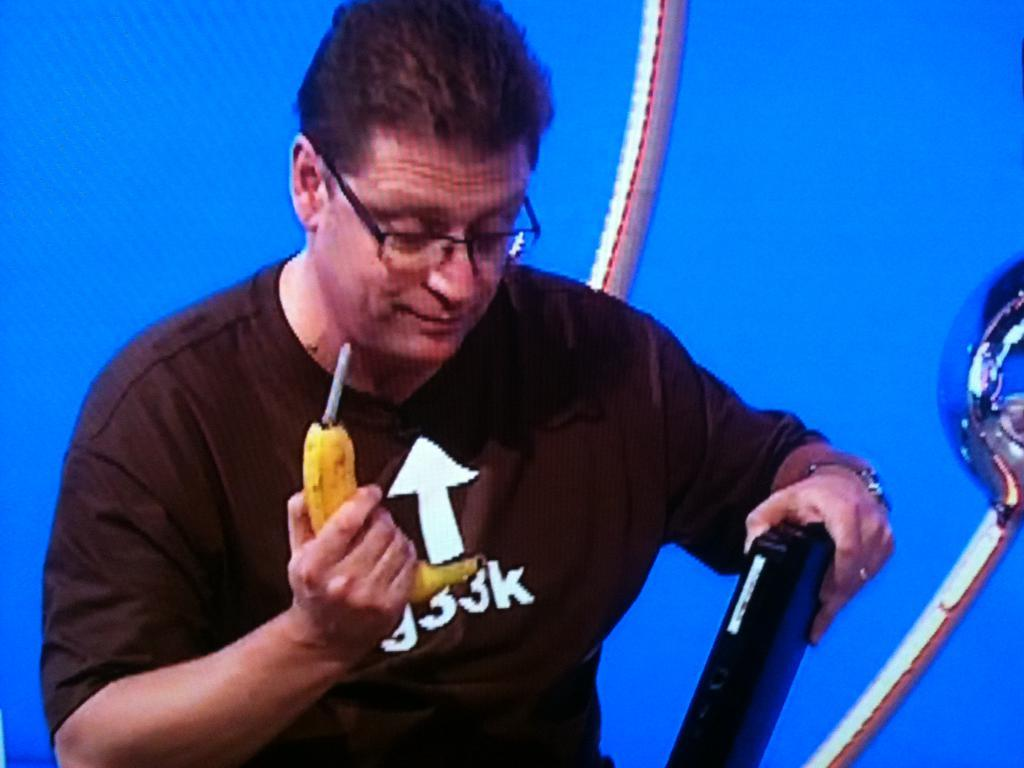What can be seen in the image? There is a person in the image. What is the person doing in the image? The person is holding objects in their hand. Can you describe the objects in the image? There are objects in the image, but their specific nature is not mentioned in the provided facts. What color is the background of the image? The background of the image is blue. What type of love story is being told on the canvas in the image? There is no canvas or love story present in the image; it features a person holding objects with a blue background. 